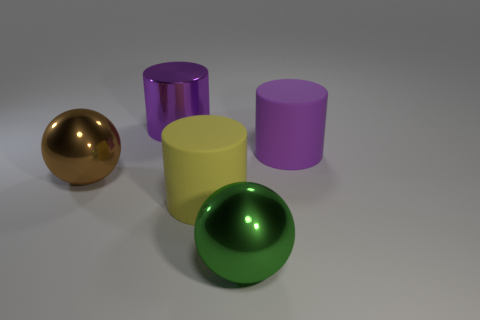Subtract all gray cubes. How many purple cylinders are left? 2 Subtract all big yellow cylinders. How many cylinders are left? 2 Add 5 big brown spheres. How many objects exist? 10 Subtract all brown cylinders. Subtract all blue spheres. How many cylinders are left? 3 Subtract all tiny red balls. Subtract all large green spheres. How many objects are left? 4 Add 1 large green metal things. How many large green metal things are left? 2 Add 4 tiny blue matte blocks. How many tiny blue matte blocks exist? 4 Subtract 0 blue blocks. How many objects are left? 5 Subtract all balls. How many objects are left? 3 